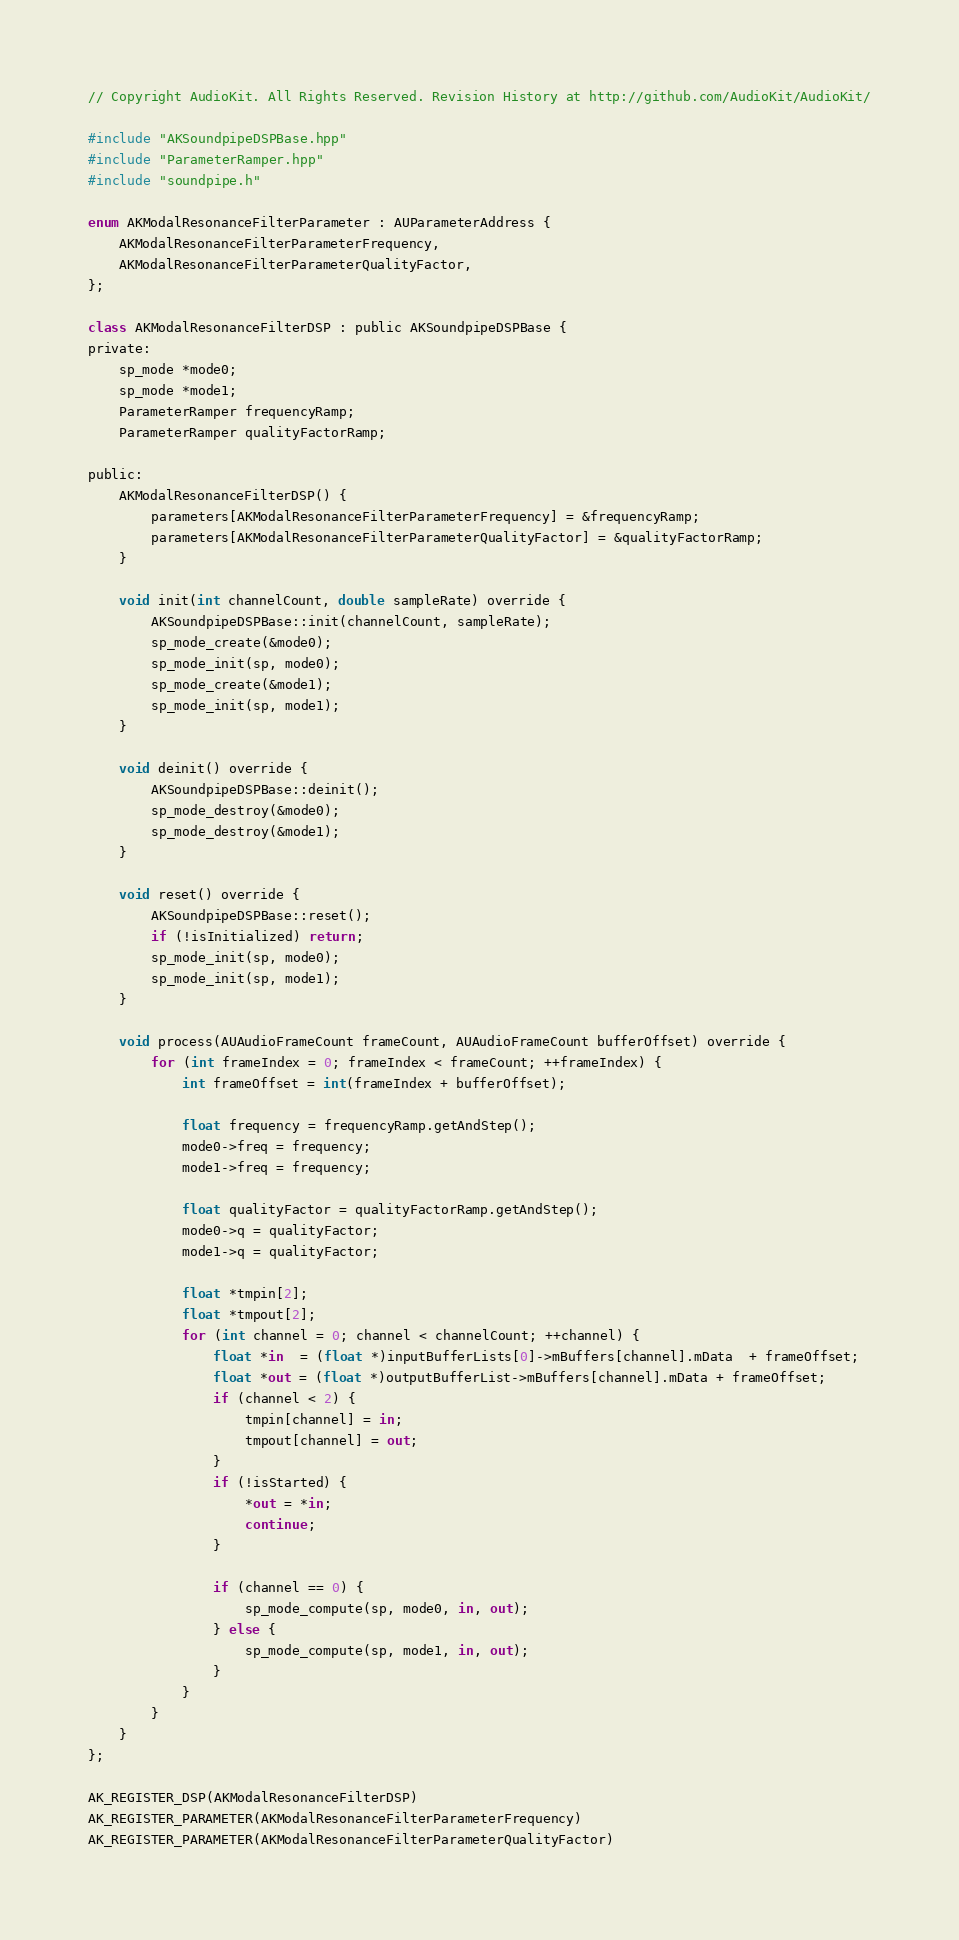<code> <loc_0><loc_0><loc_500><loc_500><_ObjectiveC_>// Copyright AudioKit. All Rights Reserved. Revision History at http://github.com/AudioKit/AudioKit/

#include "AKSoundpipeDSPBase.hpp"
#include "ParameterRamper.hpp"
#include "soundpipe.h"

enum AKModalResonanceFilterParameter : AUParameterAddress {
    AKModalResonanceFilterParameterFrequency,
    AKModalResonanceFilterParameterQualityFactor,
};

class AKModalResonanceFilterDSP : public AKSoundpipeDSPBase {
private:
    sp_mode *mode0;
    sp_mode *mode1;
    ParameterRamper frequencyRamp;
    ParameterRamper qualityFactorRamp;

public:
    AKModalResonanceFilterDSP() {
        parameters[AKModalResonanceFilterParameterFrequency] = &frequencyRamp;
        parameters[AKModalResonanceFilterParameterQualityFactor] = &qualityFactorRamp;
    }

    void init(int channelCount, double sampleRate) override {
        AKSoundpipeDSPBase::init(channelCount, sampleRate);
        sp_mode_create(&mode0);
        sp_mode_init(sp, mode0);
        sp_mode_create(&mode1);
        sp_mode_init(sp, mode1);
    }

    void deinit() override {
        AKSoundpipeDSPBase::deinit();
        sp_mode_destroy(&mode0);
        sp_mode_destroy(&mode1);
    }

    void reset() override {
        AKSoundpipeDSPBase::reset();
        if (!isInitialized) return;
        sp_mode_init(sp, mode0);
        sp_mode_init(sp, mode1);
    }

    void process(AUAudioFrameCount frameCount, AUAudioFrameCount bufferOffset) override {
        for (int frameIndex = 0; frameIndex < frameCount; ++frameIndex) {
            int frameOffset = int(frameIndex + bufferOffset);

            float frequency = frequencyRamp.getAndStep();
            mode0->freq = frequency;
            mode1->freq = frequency;

            float qualityFactor = qualityFactorRamp.getAndStep();
            mode0->q = qualityFactor;
            mode1->q = qualityFactor;

            float *tmpin[2];
            float *tmpout[2];
            for (int channel = 0; channel < channelCount; ++channel) {
                float *in  = (float *)inputBufferLists[0]->mBuffers[channel].mData  + frameOffset;
                float *out = (float *)outputBufferList->mBuffers[channel].mData + frameOffset;
                if (channel < 2) {
                    tmpin[channel] = in;
                    tmpout[channel] = out;
                }
                if (!isStarted) {
                    *out = *in;
                    continue;
                }

                if (channel == 0) {
                    sp_mode_compute(sp, mode0, in, out);
                } else {
                    sp_mode_compute(sp, mode1, in, out);
                }
            }
        }
    }
};

AK_REGISTER_DSP(AKModalResonanceFilterDSP)
AK_REGISTER_PARAMETER(AKModalResonanceFilterParameterFrequency)
AK_REGISTER_PARAMETER(AKModalResonanceFilterParameterQualityFactor)
</code> 